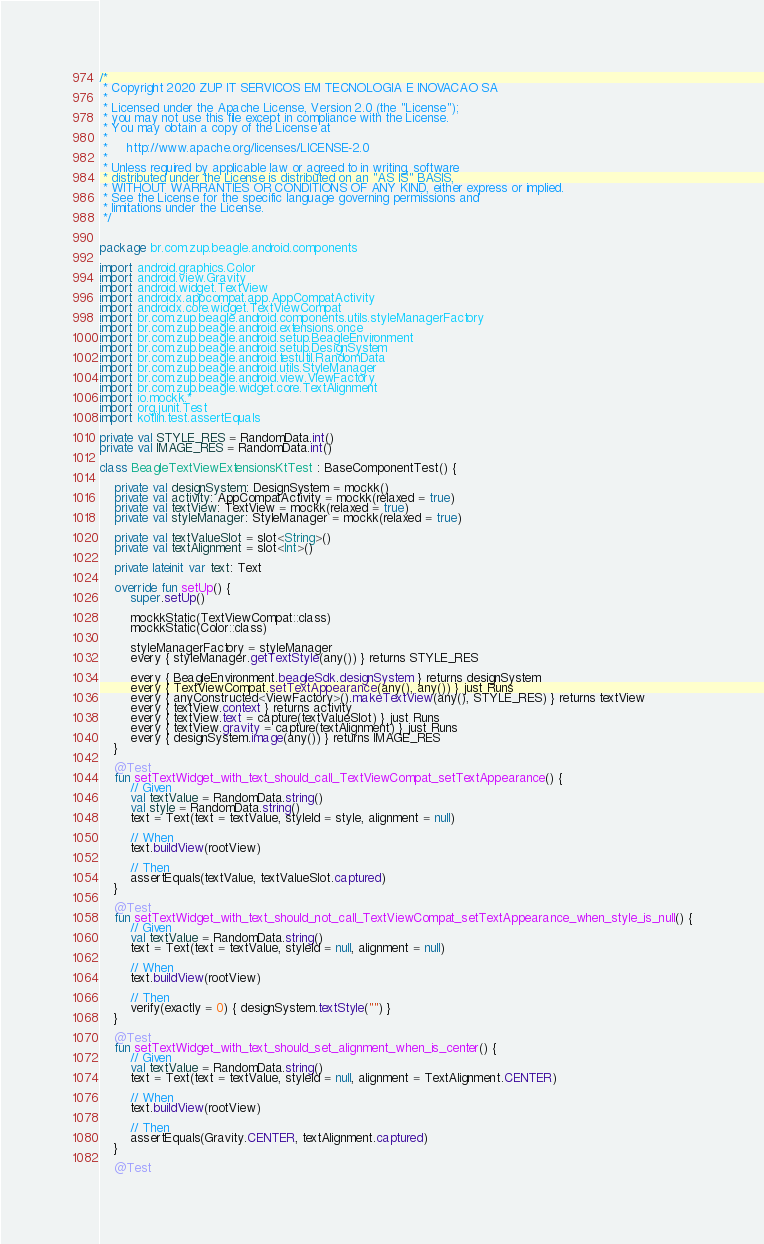Convert code to text. <code><loc_0><loc_0><loc_500><loc_500><_Kotlin_>/*
 * Copyright 2020 ZUP IT SERVICOS EM TECNOLOGIA E INOVACAO SA
 *
 * Licensed under the Apache License, Version 2.0 (the "License");
 * you may not use this file except in compliance with the License.
 * You may obtain a copy of the License at
 *
 *     http://www.apache.org/licenses/LICENSE-2.0
 *
 * Unless required by applicable law or agreed to in writing, software
 * distributed under the License is distributed on an "AS IS" BASIS,
 * WITHOUT WARRANTIES OR CONDITIONS OF ANY KIND, either express or implied.
 * See the License for the specific language governing permissions and
 * limitations under the License.
 */


package br.com.zup.beagle.android.components

import android.graphics.Color
import android.view.Gravity
import android.widget.TextView
import androidx.appcompat.app.AppCompatActivity
import androidx.core.widget.TextViewCompat
import br.com.zup.beagle.android.components.utils.styleManagerFactory
import br.com.zup.beagle.android.extensions.once
import br.com.zup.beagle.android.setup.BeagleEnvironment
import br.com.zup.beagle.android.setup.DesignSystem
import br.com.zup.beagle.android.testutil.RandomData
import br.com.zup.beagle.android.utils.StyleManager
import br.com.zup.beagle.android.view.ViewFactory
import br.com.zup.beagle.widget.core.TextAlignment
import io.mockk.*
import org.junit.Test
import kotlin.test.assertEquals

private val STYLE_RES = RandomData.int()
private val IMAGE_RES = RandomData.int()

class BeagleTextViewExtensionsKtTest : BaseComponentTest() {

    private val designSystem: DesignSystem = mockk()
    private val activity: AppCompatActivity = mockk(relaxed = true)
    private val textView: TextView = mockk(relaxed = true)
    private val styleManager: StyleManager = mockk(relaxed = true)

    private val textValueSlot = slot<String>()
    private val textAlignment = slot<Int>()

    private lateinit var text: Text

    override fun setUp() {
        super.setUp()

        mockkStatic(TextViewCompat::class)
        mockkStatic(Color::class)

        styleManagerFactory = styleManager
        every { styleManager.getTextStyle(any()) } returns STYLE_RES

        every { BeagleEnvironment.beagleSdk.designSystem } returns designSystem
        every { TextViewCompat.setTextAppearance(any(), any()) } just Runs
        every { anyConstructed<ViewFactory>().makeTextView(any(), STYLE_RES) } returns textView
        every { textView.context } returns activity
        every { textView.text = capture(textValueSlot) } just Runs
        every { textView.gravity = capture(textAlignment) } just Runs
        every { designSystem.image(any()) } returns IMAGE_RES
    }

    @Test
    fun setTextWidget_with_text_should_call_TextViewCompat_setTextAppearance() {
        // Given
        val textValue = RandomData.string()
        val style = RandomData.string()
        text = Text(text = textValue, styleId = style, alignment = null)

        // When
        text.buildView(rootView)

        // Then
        assertEquals(textValue, textValueSlot.captured)
    }

    @Test
    fun setTextWidget_with_text_should_not_call_TextViewCompat_setTextAppearance_when_style_is_null() {
        // Given
        val textValue = RandomData.string()
        text = Text(text = textValue, styleId = null, alignment = null)

        // When
        text.buildView(rootView)

        // Then
        verify(exactly = 0) { designSystem.textStyle("") }
    }

    @Test
    fun setTextWidget_with_text_should_set_alignment_when_is_center() {
        // Given
        val textValue = RandomData.string()
        text = Text(text = textValue, styleId = null, alignment = TextAlignment.CENTER)

        // When
        text.buildView(rootView)

        // Then
        assertEquals(Gravity.CENTER, textAlignment.captured)
    }

    @Test</code> 